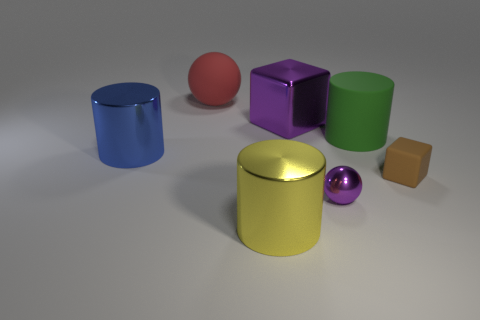What is the shape of the shiny thing that is the same color as the small sphere?
Offer a terse response. Cube. There is a purple metallic block that is in front of the red matte object; is it the same size as the small ball?
Offer a terse response. No. What shape is the blue object that is the same size as the matte cylinder?
Your response must be concise. Cylinder. Does the tiny purple shiny thing have the same shape as the large red thing?
Provide a short and direct response. Yes. What number of green objects have the same shape as the yellow metallic thing?
Your answer should be compact. 1. There is a red rubber sphere; what number of tiny shiny objects are in front of it?
Provide a succinct answer. 1. Does the cube left of the small brown object have the same color as the small metal ball?
Your answer should be very brief. Yes. How many brown things have the same size as the red ball?
Offer a very short reply. 0. There is a big object that is made of the same material as the red ball; what shape is it?
Ensure brevity in your answer.  Cylinder. Is there a big block that has the same color as the tiny ball?
Offer a very short reply. Yes. 